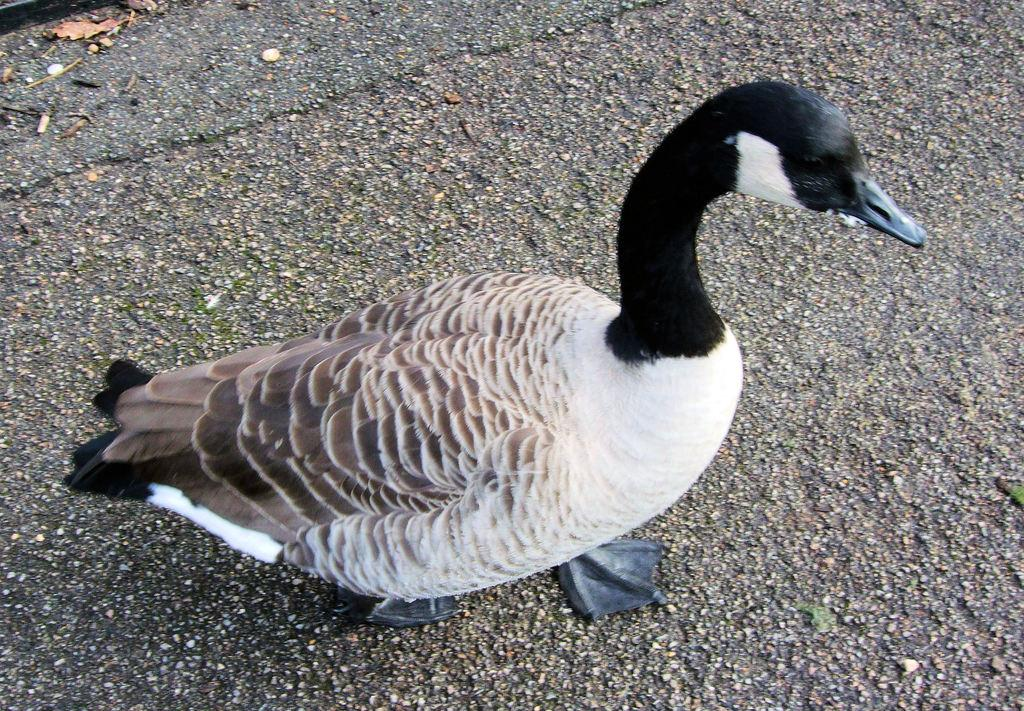What type of animal is in the picture? There is a duck in the picture. Can you describe the coloring of the duck? The duck has white, black, and brown coloring. How does the duck's desire for the ocean affect its behavior in the picture? There is no indication in the image that the duck has a desire for the ocean, and therefore its behavior is not affected by this desire. 